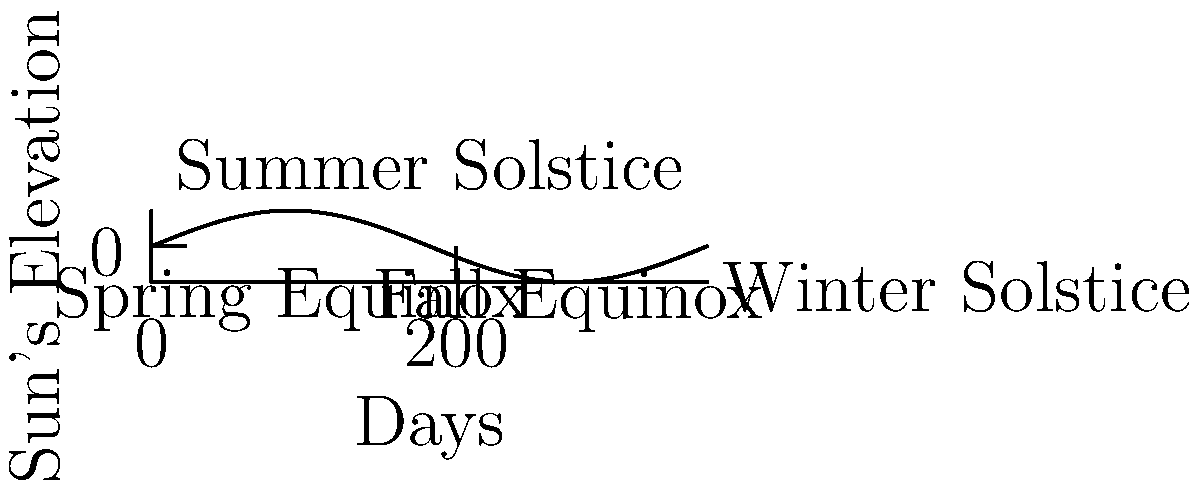How does the Sun's changing path across the sky throughout the year affect crop growth, and what adjustments might you need to make in your farming practices to optimize yield? 1. Sun's path variation: The graph shows how the Sun's elevation changes over the year. The highest point represents the summer solstice, while the lowest point is the winter solstice.

2. Impact on daylight hours: 
   - Longer days in summer (around day 182) provide more sunlight for photosynthesis.
   - Shorter days in winter (around day 365) limit available sunlight.

3. Effect on crop growth:
   - More sunlight in summer accelerates growth and ripening.
   - Less sunlight in winter slows growth and may cause dormancy in some crops.

4. Temperature variations:
   - Higher Sun elevation in summer increases temperatures.
   - Lower Sun elevation in winter decreases temperatures.

5. Farming adjustments:
   - Planting times: Adjust based on expected sunlight and temperature.
   - Crop selection: Choose crops suited to your location's sunlight patterns.
   - Irrigation: Increase during longer, hotter days of summer.
   - Protection: Provide shade or cooling for sensitive crops in peak summer.
   - Greenhouse use: Extend growing season during periods of less sunlight.

6. Crop rotation:
   - Plan rotations to maximize use of available sunlight throughout the year.
   - Consider fast-growing crops for shorter daylight periods.

7. Soil management:
   - Adjust fertilization schedules based on crop growth rates affected by sunlight.
   - Implement cover crops during low-sunlight periods to protect and enrich soil.
Answer: Adjust planting times, crop selection, irrigation, and protection methods based on seasonal sunlight patterns to optimize yield. 